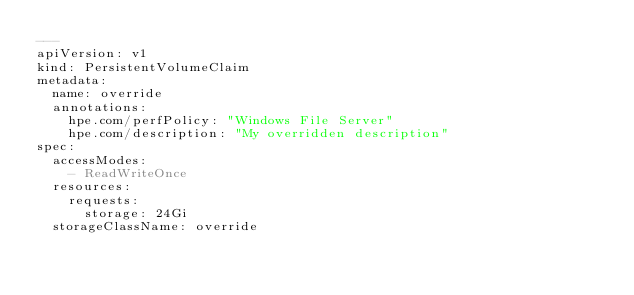Convert code to text. <code><loc_0><loc_0><loc_500><loc_500><_YAML_>---
apiVersion: v1
kind: PersistentVolumeClaim
metadata:
  name: override
  annotations:
    hpe.com/perfPolicy: "Windows File Server"
    hpe.com/description: "My overridden description"
spec:
  accessModes:
    - ReadWriteOnce
  resources:
    requests:
      storage: 24Gi
  storageClassName: override
</code> 